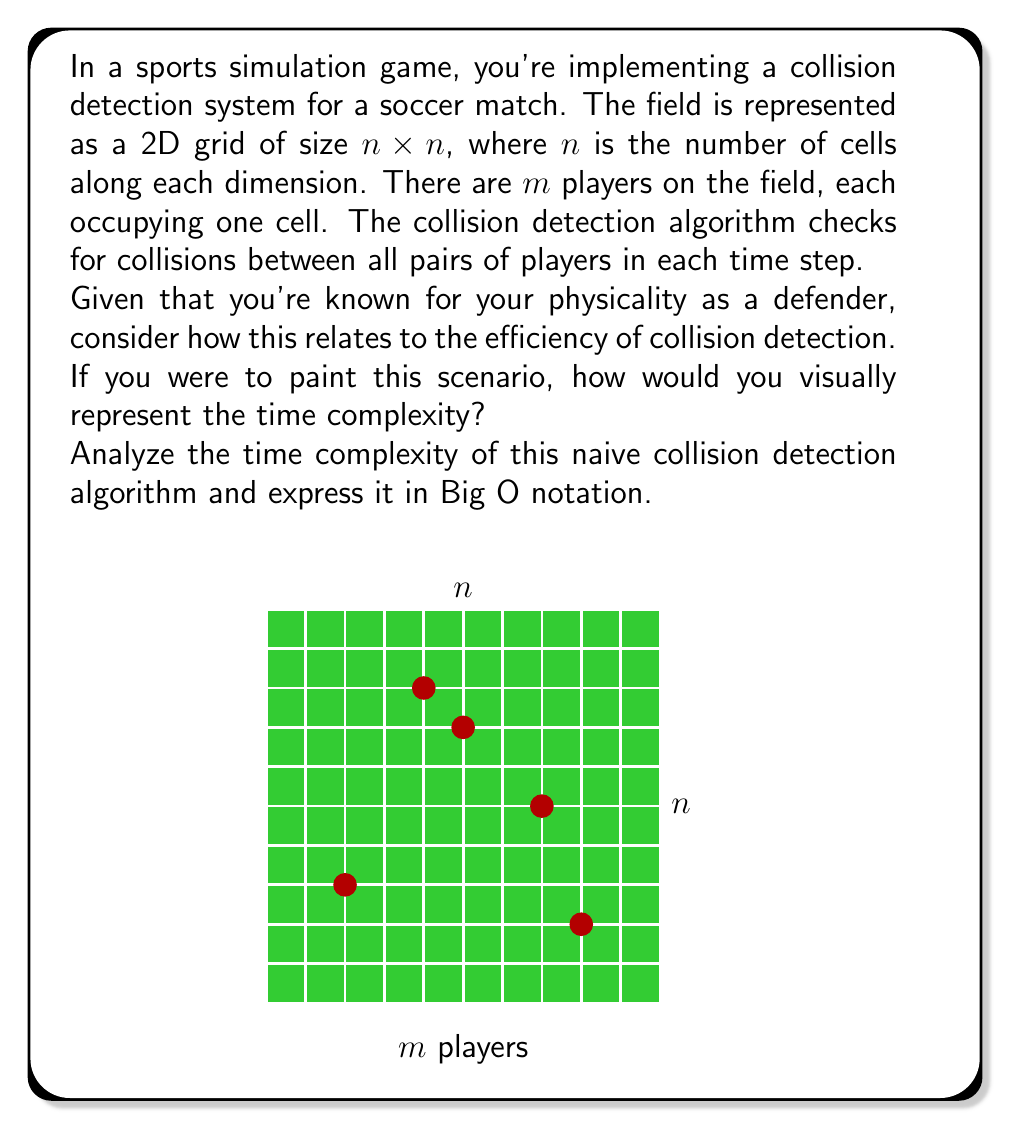Could you help me with this problem? Let's break down the analysis step-by-step:

1) First, we need to understand what the algorithm does. It checks for collisions between all pairs of players in each time step.

2) With $m$ players, we need to compare each player with every other player. This is similar to choosing 2 players from $m$ players, which gives us $\binom{m}{2}$ comparisons.

3) The number of comparisons can be calculated as:

   $$\binom{m}{2} = \frac{m(m-1)}{2}$$

4) This expression can be simplified to $O(m^2)$ in Big O notation, as we're interested in the growth rate as $m$ becomes large, and constants and lower-order terms are dropped.

5) The size of the grid ($n \times n$) doesn't affect the time complexity in this naive approach, as we're checking all pairs regardless of their positions.

6) From a defender's perspective, this quadratic complexity reflects the challenge of keeping track of all potential collisions, much like how a physical defender needs to be aware of all players' positions.

7) Visually, you could represent this as a square grid where each cell represents a comparison between two players. The area of this grid grows quadratically with the number of players, similar to how the complexity grows.
Answer: $O(m^2)$, where $m$ is the number of players 